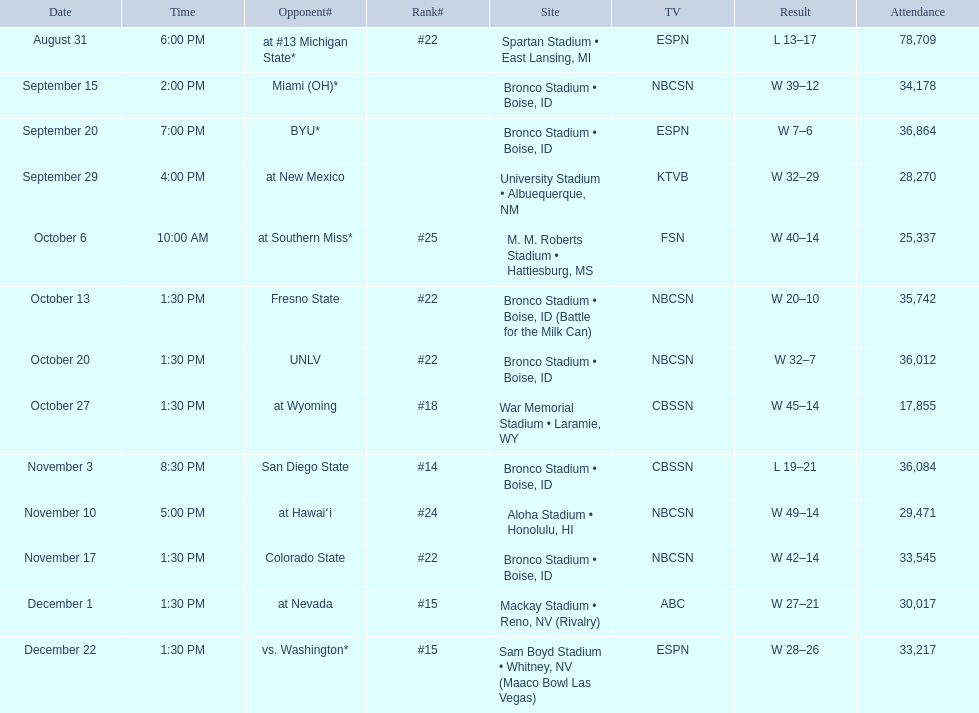Who did boise state compete against? At #13 michigan state*, miami (oh)*, byu*, at new mexico, at southern miss*, fresno state, unlv, at wyoming, san diego state, at hawaiʻi, colorado state, at nevada, vs. washington*. Which of these opposing teams were ranked? At #13 michigan state*, #22, at southern miss*, #25, fresno state, #22, unlv, #22, at wyoming, #18, san diego state, #14. Which one held the top rank among them? San Diego State. 